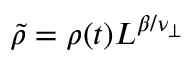<formula> <loc_0><loc_0><loc_500><loc_500>\tilde { \rho } = \rho ( t ) L ^ { \beta / \nu _ { \perp } }</formula> 